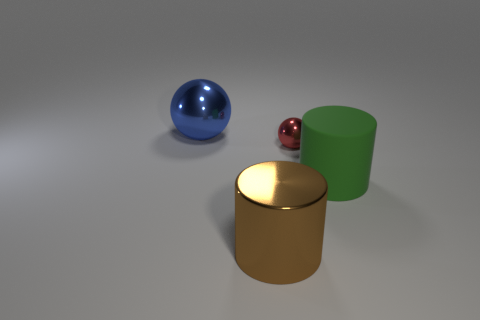Is the number of big shiny cylinders that are to the right of the big rubber thing the same as the number of brown metallic things that are to the right of the red ball? Yes, the number of large shiny cylinders to the right of the large rubber object is indeed equivalent to the number of brown metallic objects to the right of the red ball; each group consists of one object. 